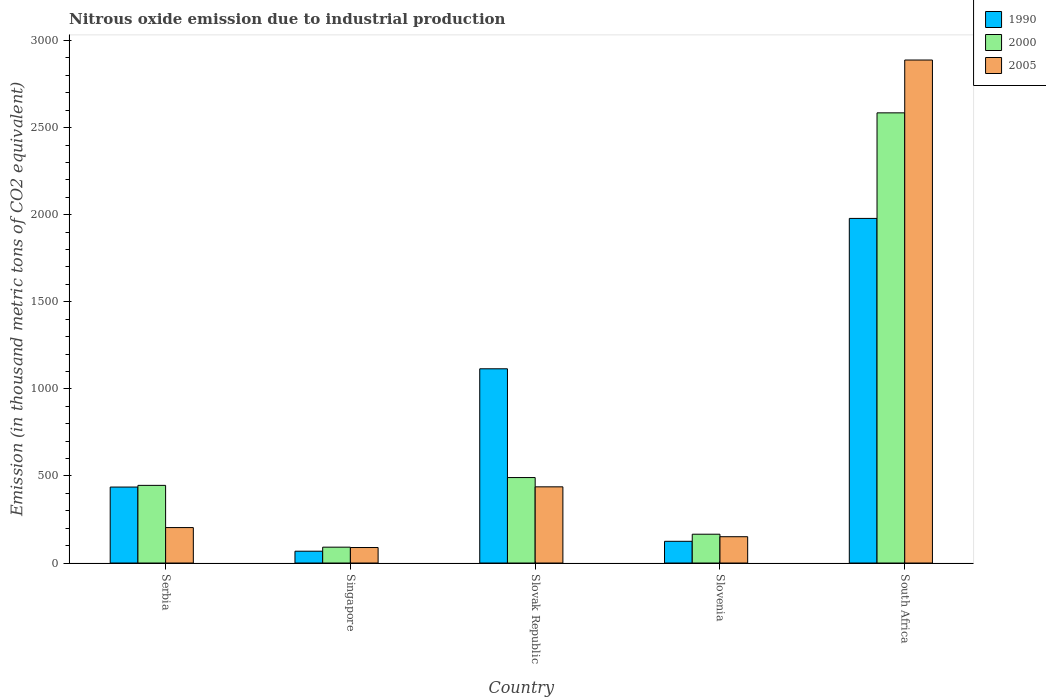How many groups of bars are there?
Offer a terse response. 5. How many bars are there on the 5th tick from the left?
Offer a terse response. 3. What is the label of the 1st group of bars from the left?
Give a very brief answer. Serbia. What is the amount of nitrous oxide emitted in 2000 in Slovak Republic?
Provide a succinct answer. 490.8. Across all countries, what is the maximum amount of nitrous oxide emitted in 1990?
Keep it short and to the point. 1978.6. Across all countries, what is the minimum amount of nitrous oxide emitted in 1990?
Ensure brevity in your answer.  67.9. In which country was the amount of nitrous oxide emitted in 2000 maximum?
Ensure brevity in your answer.  South Africa. In which country was the amount of nitrous oxide emitted in 1990 minimum?
Make the answer very short. Singapore. What is the total amount of nitrous oxide emitted in 2000 in the graph?
Provide a succinct answer. 3778. What is the difference between the amount of nitrous oxide emitted in 2005 in Singapore and that in Slovak Republic?
Give a very brief answer. -348.5. What is the difference between the amount of nitrous oxide emitted in 2000 in Serbia and the amount of nitrous oxide emitted in 1990 in Slovenia?
Give a very brief answer. 321.2. What is the average amount of nitrous oxide emitted in 1990 per country?
Offer a very short reply. 744.52. What is the difference between the amount of nitrous oxide emitted of/in 2000 and amount of nitrous oxide emitted of/in 1990 in Singapore?
Ensure brevity in your answer.  23.2. In how many countries, is the amount of nitrous oxide emitted in 1990 greater than 2700 thousand metric tons?
Keep it short and to the point. 0. What is the ratio of the amount of nitrous oxide emitted in 1990 in Singapore to that in Slovak Republic?
Offer a very short reply. 0.06. Is the amount of nitrous oxide emitted in 1990 in Serbia less than that in Slovak Republic?
Give a very brief answer. Yes. Is the difference between the amount of nitrous oxide emitted in 2000 in Slovenia and South Africa greater than the difference between the amount of nitrous oxide emitted in 1990 in Slovenia and South Africa?
Offer a very short reply. No. What is the difference between the highest and the second highest amount of nitrous oxide emitted in 1990?
Your answer should be compact. 863.4. What is the difference between the highest and the lowest amount of nitrous oxide emitted in 1990?
Keep it short and to the point. 1910.7. In how many countries, is the amount of nitrous oxide emitted in 2005 greater than the average amount of nitrous oxide emitted in 2005 taken over all countries?
Your answer should be compact. 1. What does the 2nd bar from the left in Singapore represents?
Keep it short and to the point. 2000. How many bars are there?
Provide a succinct answer. 15. Are all the bars in the graph horizontal?
Keep it short and to the point. No. Are the values on the major ticks of Y-axis written in scientific E-notation?
Provide a succinct answer. No. Does the graph contain grids?
Your answer should be compact. No. How are the legend labels stacked?
Ensure brevity in your answer.  Vertical. What is the title of the graph?
Make the answer very short. Nitrous oxide emission due to industrial production. Does "1994" appear as one of the legend labels in the graph?
Provide a succinct answer. No. What is the label or title of the X-axis?
Make the answer very short. Country. What is the label or title of the Y-axis?
Keep it short and to the point. Emission (in thousand metric tons of CO2 equivalent). What is the Emission (in thousand metric tons of CO2 equivalent) in 1990 in Serbia?
Ensure brevity in your answer.  436.2. What is the Emission (in thousand metric tons of CO2 equivalent) in 2000 in Serbia?
Give a very brief answer. 445.9. What is the Emission (in thousand metric tons of CO2 equivalent) of 2005 in Serbia?
Your answer should be compact. 203.6. What is the Emission (in thousand metric tons of CO2 equivalent) in 1990 in Singapore?
Offer a terse response. 67.9. What is the Emission (in thousand metric tons of CO2 equivalent) of 2000 in Singapore?
Make the answer very short. 91.1. What is the Emission (in thousand metric tons of CO2 equivalent) of 2005 in Singapore?
Your answer should be compact. 89. What is the Emission (in thousand metric tons of CO2 equivalent) of 1990 in Slovak Republic?
Your response must be concise. 1115.2. What is the Emission (in thousand metric tons of CO2 equivalent) in 2000 in Slovak Republic?
Give a very brief answer. 490.8. What is the Emission (in thousand metric tons of CO2 equivalent) in 2005 in Slovak Republic?
Make the answer very short. 437.5. What is the Emission (in thousand metric tons of CO2 equivalent) of 1990 in Slovenia?
Your response must be concise. 124.7. What is the Emission (in thousand metric tons of CO2 equivalent) in 2000 in Slovenia?
Offer a terse response. 165.5. What is the Emission (in thousand metric tons of CO2 equivalent) in 2005 in Slovenia?
Ensure brevity in your answer.  151.1. What is the Emission (in thousand metric tons of CO2 equivalent) in 1990 in South Africa?
Offer a very short reply. 1978.6. What is the Emission (in thousand metric tons of CO2 equivalent) of 2000 in South Africa?
Offer a terse response. 2584.7. What is the Emission (in thousand metric tons of CO2 equivalent) of 2005 in South Africa?
Your answer should be very brief. 2888. Across all countries, what is the maximum Emission (in thousand metric tons of CO2 equivalent) in 1990?
Ensure brevity in your answer.  1978.6. Across all countries, what is the maximum Emission (in thousand metric tons of CO2 equivalent) in 2000?
Keep it short and to the point. 2584.7. Across all countries, what is the maximum Emission (in thousand metric tons of CO2 equivalent) in 2005?
Provide a short and direct response. 2888. Across all countries, what is the minimum Emission (in thousand metric tons of CO2 equivalent) in 1990?
Give a very brief answer. 67.9. Across all countries, what is the minimum Emission (in thousand metric tons of CO2 equivalent) in 2000?
Your response must be concise. 91.1. Across all countries, what is the minimum Emission (in thousand metric tons of CO2 equivalent) of 2005?
Offer a terse response. 89. What is the total Emission (in thousand metric tons of CO2 equivalent) of 1990 in the graph?
Ensure brevity in your answer.  3722.6. What is the total Emission (in thousand metric tons of CO2 equivalent) in 2000 in the graph?
Make the answer very short. 3778. What is the total Emission (in thousand metric tons of CO2 equivalent) in 2005 in the graph?
Your answer should be compact. 3769.2. What is the difference between the Emission (in thousand metric tons of CO2 equivalent) of 1990 in Serbia and that in Singapore?
Keep it short and to the point. 368.3. What is the difference between the Emission (in thousand metric tons of CO2 equivalent) in 2000 in Serbia and that in Singapore?
Your answer should be compact. 354.8. What is the difference between the Emission (in thousand metric tons of CO2 equivalent) in 2005 in Serbia and that in Singapore?
Provide a succinct answer. 114.6. What is the difference between the Emission (in thousand metric tons of CO2 equivalent) in 1990 in Serbia and that in Slovak Republic?
Your response must be concise. -679. What is the difference between the Emission (in thousand metric tons of CO2 equivalent) of 2000 in Serbia and that in Slovak Republic?
Your response must be concise. -44.9. What is the difference between the Emission (in thousand metric tons of CO2 equivalent) of 2005 in Serbia and that in Slovak Republic?
Offer a terse response. -233.9. What is the difference between the Emission (in thousand metric tons of CO2 equivalent) of 1990 in Serbia and that in Slovenia?
Offer a very short reply. 311.5. What is the difference between the Emission (in thousand metric tons of CO2 equivalent) in 2000 in Serbia and that in Slovenia?
Make the answer very short. 280.4. What is the difference between the Emission (in thousand metric tons of CO2 equivalent) of 2005 in Serbia and that in Slovenia?
Offer a very short reply. 52.5. What is the difference between the Emission (in thousand metric tons of CO2 equivalent) in 1990 in Serbia and that in South Africa?
Provide a succinct answer. -1542.4. What is the difference between the Emission (in thousand metric tons of CO2 equivalent) in 2000 in Serbia and that in South Africa?
Offer a very short reply. -2138.8. What is the difference between the Emission (in thousand metric tons of CO2 equivalent) of 2005 in Serbia and that in South Africa?
Your response must be concise. -2684.4. What is the difference between the Emission (in thousand metric tons of CO2 equivalent) of 1990 in Singapore and that in Slovak Republic?
Offer a terse response. -1047.3. What is the difference between the Emission (in thousand metric tons of CO2 equivalent) in 2000 in Singapore and that in Slovak Republic?
Provide a succinct answer. -399.7. What is the difference between the Emission (in thousand metric tons of CO2 equivalent) of 2005 in Singapore and that in Slovak Republic?
Provide a succinct answer. -348.5. What is the difference between the Emission (in thousand metric tons of CO2 equivalent) of 1990 in Singapore and that in Slovenia?
Keep it short and to the point. -56.8. What is the difference between the Emission (in thousand metric tons of CO2 equivalent) of 2000 in Singapore and that in Slovenia?
Provide a succinct answer. -74.4. What is the difference between the Emission (in thousand metric tons of CO2 equivalent) of 2005 in Singapore and that in Slovenia?
Your answer should be compact. -62.1. What is the difference between the Emission (in thousand metric tons of CO2 equivalent) of 1990 in Singapore and that in South Africa?
Provide a succinct answer. -1910.7. What is the difference between the Emission (in thousand metric tons of CO2 equivalent) of 2000 in Singapore and that in South Africa?
Offer a terse response. -2493.6. What is the difference between the Emission (in thousand metric tons of CO2 equivalent) of 2005 in Singapore and that in South Africa?
Keep it short and to the point. -2799. What is the difference between the Emission (in thousand metric tons of CO2 equivalent) of 1990 in Slovak Republic and that in Slovenia?
Your answer should be very brief. 990.5. What is the difference between the Emission (in thousand metric tons of CO2 equivalent) in 2000 in Slovak Republic and that in Slovenia?
Provide a succinct answer. 325.3. What is the difference between the Emission (in thousand metric tons of CO2 equivalent) in 2005 in Slovak Republic and that in Slovenia?
Keep it short and to the point. 286.4. What is the difference between the Emission (in thousand metric tons of CO2 equivalent) of 1990 in Slovak Republic and that in South Africa?
Keep it short and to the point. -863.4. What is the difference between the Emission (in thousand metric tons of CO2 equivalent) of 2000 in Slovak Republic and that in South Africa?
Ensure brevity in your answer.  -2093.9. What is the difference between the Emission (in thousand metric tons of CO2 equivalent) in 2005 in Slovak Republic and that in South Africa?
Provide a short and direct response. -2450.5. What is the difference between the Emission (in thousand metric tons of CO2 equivalent) of 1990 in Slovenia and that in South Africa?
Offer a very short reply. -1853.9. What is the difference between the Emission (in thousand metric tons of CO2 equivalent) of 2000 in Slovenia and that in South Africa?
Give a very brief answer. -2419.2. What is the difference between the Emission (in thousand metric tons of CO2 equivalent) in 2005 in Slovenia and that in South Africa?
Your answer should be very brief. -2736.9. What is the difference between the Emission (in thousand metric tons of CO2 equivalent) in 1990 in Serbia and the Emission (in thousand metric tons of CO2 equivalent) in 2000 in Singapore?
Make the answer very short. 345.1. What is the difference between the Emission (in thousand metric tons of CO2 equivalent) in 1990 in Serbia and the Emission (in thousand metric tons of CO2 equivalent) in 2005 in Singapore?
Provide a succinct answer. 347.2. What is the difference between the Emission (in thousand metric tons of CO2 equivalent) in 2000 in Serbia and the Emission (in thousand metric tons of CO2 equivalent) in 2005 in Singapore?
Provide a short and direct response. 356.9. What is the difference between the Emission (in thousand metric tons of CO2 equivalent) of 1990 in Serbia and the Emission (in thousand metric tons of CO2 equivalent) of 2000 in Slovak Republic?
Your answer should be compact. -54.6. What is the difference between the Emission (in thousand metric tons of CO2 equivalent) of 1990 in Serbia and the Emission (in thousand metric tons of CO2 equivalent) of 2005 in Slovak Republic?
Provide a succinct answer. -1.3. What is the difference between the Emission (in thousand metric tons of CO2 equivalent) of 1990 in Serbia and the Emission (in thousand metric tons of CO2 equivalent) of 2000 in Slovenia?
Offer a terse response. 270.7. What is the difference between the Emission (in thousand metric tons of CO2 equivalent) of 1990 in Serbia and the Emission (in thousand metric tons of CO2 equivalent) of 2005 in Slovenia?
Your response must be concise. 285.1. What is the difference between the Emission (in thousand metric tons of CO2 equivalent) of 2000 in Serbia and the Emission (in thousand metric tons of CO2 equivalent) of 2005 in Slovenia?
Your answer should be compact. 294.8. What is the difference between the Emission (in thousand metric tons of CO2 equivalent) in 1990 in Serbia and the Emission (in thousand metric tons of CO2 equivalent) in 2000 in South Africa?
Give a very brief answer. -2148.5. What is the difference between the Emission (in thousand metric tons of CO2 equivalent) in 1990 in Serbia and the Emission (in thousand metric tons of CO2 equivalent) in 2005 in South Africa?
Provide a succinct answer. -2451.8. What is the difference between the Emission (in thousand metric tons of CO2 equivalent) in 2000 in Serbia and the Emission (in thousand metric tons of CO2 equivalent) in 2005 in South Africa?
Ensure brevity in your answer.  -2442.1. What is the difference between the Emission (in thousand metric tons of CO2 equivalent) in 1990 in Singapore and the Emission (in thousand metric tons of CO2 equivalent) in 2000 in Slovak Republic?
Offer a very short reply. -422.9. What is the difference between the Emission (in thousand metric tons of CO2 equivalent) in 1990 in Singapore and the Emission (in thousand metric tons of CO2 equivalent) in 2005 in Slovak Republic?
Offer a very short reply. -369.6. What is the difference between the Emission (in thousand metric tons of CO2 equivalent) of 2000 in Singapore and the Emission (in thousand metric tons of CO2 equivalent) of 2005 in Slovak Republic?
Provide a succinct answer. -346.4. What is the difference between the Emission (in thousand metric tons of CO2 equivalent) in 1990 in Singapore and the Emission (in thousand metric tons of CO2 equivalent) in 2000 in Slovenia?
Make the answer very short. -97.6. What is the difference between the Emission (in thousand metric tons of CO2 equivalent) of 1990 in Singapore and the Emission (in thousand metric tons of CO2 equivalent) of 2005 in Slovenia?
Offer a very short reply. -83.2. What is the difference between the Emission (in thousand metric tons of CO2 equivalent) of 2000 in Singapore and the Emission (in thousand metric tons of CO2 equivalent) of 2005 in Slovenia?
Provide a succinct answer. -60. What is the difference between the Emission (in thousand metric tons of CO2 equivalent) in 1990 in Singapore and the Emission (in thousand metric tons of CO2 equivalent) in 2000 in South Africa?
Your answer should be very brief. -2516.8. What is the difference between the Emission (in thousand metric tons of CO2 equivalent) in 1990 in Singapore and the Emission (in thousand metric tons of CO2 equivalent) in 2005 in South Africa?
Provide a succinct answer. -2820.1. What is the difference between the Emission (in thousand metric tons of CO2 equivalent) in 2000 in Singapore and the Emission (in thousand metric tons of CO2 equivalent) in 2005 in South Africa?
Your answer should be very brief. -2796.9. What is the difference between the Emission (in thousand metric tons of CO2 equivalent) in 1990 in Slovak Republic and the Emission (in thousand metric tons of CO2 equivalent) in 2000 in Slovenia?
Provide a succinct answer. 949.7. What is the difference between the Emission (in thousand metric tons of CO2 equivalent) in 1990 in Slovak Republic and the Emission (in thousand metric tons of CO2 equivalent) in 2005 in Slovenia?
Ensure brevity in your answer.  964.1. What is the difference between the Emission (in thousand metric tons of CO2 equivalent) of 2000 in Slovak Republic and the Emission (in thousand metric tons of CO2 equivalent) of 2005 in Slovenia?
Your answer should be very brief. 339.7. What is the difference between the Emission (in thousand metric tons of CO2 equivalent) in 1990 in Slovak Republic and the Emission (in thousand metric tons of CO2 equivalent) in 2000 in South Africa?
Your answer should be compact. -1469.5. What is the difference between the Emission (in thousand metric tons of CO2 equivalent) of 1990 in Slovak Republic and the Emission (in thousand metric tons of CO2 equivalent) of 2005 in South Africa?
Make the answer very short. -1772.8. What is the difference between the Emission (in thousand metric tons of CO2 equivalent) in 2000 in Slovak Republic and the Emission (in thousand metric tons of CO2 equivalent) in 2005 in South Africa?
Make the answer very short. -2397.2. What is the difference between the Emission (in thousand metric tons of CO2 equivalent) in 1990 in Slovenia and the Emission (in thousand metric tons of CO2 equivalent) in 2000 in South Africa?
Your response must be concise. -2460. What is the difference between the Emission (in thousand metric tons of CO2 equivalent) in 1990 in Slovenia and the Emission (in thousand metric tons of CO2 equivalent) in 2005 in South Africa?
Your answer should be very brief. -2763.3. What is the difference between the Emission (in thousand metric tons of CO2 equivalent) of 2000 in Slovenia and the Emission (in thousand metric tons of CO2 equivalent) of 2005 in South Africa?
Your response must be concise. -2722.5. What is the average Emission (in thousand metric tons of CO2 equivalent) of 1990 per country?
Your response must be concise. 744.52. What is the average Emission (in thousand metric tons of CO2 equivalent) of 2000 per country?
Provide a succinct answer. 755.6. What is the average Emission (in thousand metric tons of CO2 equivalent) in 2005 per country?
Make the answer very short. 753.84. What is the difference between the Emission (in thousand metric tons of CO2 equivalent) of 1990 and Emission (in thousand metric tons of CO2 equivalent) of 2000 in Serbia?
Your answer should be compact. -9.7. What is the difference between the Emission (in thousand metric tons of CO2 equivalent) in 1990 and Emission (in thousand metric tons of CO2 equivalent) in 2005 in Serbia?
Your answer should be very brief. 232.6. What is the difference between the Emission (in thousand metric tons of CO2 equivalent) in 2000 and Emission (in thousand metric tons of CO2 equivalent) in 2005 in Serbia?
Your response must be concise. 242.3. What is the difference between the Emission (in thousand metric tons of CO2 equivalent) in 1990 and Emission (in thousand metric tons of CO2 equivalent) in 2000 in Singapore?
Ensure brevity in your answer.  -23.2. What is the difference between the Emission (in thousand metric tons of CO2 equivalent) in 1990 and Emission (in thousand metric tons of CO2 equivalent) in 2005 in Singapore?
Provide a short and direct response. -21.1. What is the difference between the Emission (in thousand metric tons of CO2 equivalent) in 1990 and Emission (in thousand metric tons of CO2 equivalent) in 2000 in Slovak Republic?
Ensure brevity in your answer.  624.4. What is the difference between the Emission (in thousand metric tons of CO2 equivalent) in 1990 and Emission (in thousand metric tons of CO2 equivalent) in 2005 in Slovak Republic?
Provide a short and direct response. 677.7. What is the difference between the Emission (in thousand metric tons of CO2 equivalent) in 2000 and Emission (in thousand metric tons of CO2 equivalent) in 2005 in Slovak Republic?
Your response must be concise. 53.3. What is the difference between the Emission (in thousand metric tons of CO2 equivalent) of 1990 and Emission (in thousand metric tons of CO2 equivalent) of 2000 in Slovenia?
Make the answer very short. -40.8. What is the difference between the Emission (in thousand metric tons of CO2 equivalent) in 1990 and Emission (in thousand metric tons of CO2 equivalent) in 2005 in Slovenia?
Provide a short and direct response. -26.4. What is the difference between the Emission (in thousand metric tons of CO2 equivalent) in 1990 and Emission (in thousand metric tons of CO2 equivalent) in 2000 in South Africa?
Your answer should be compact. -606.1. What is the difference between the Emission (in thousand metric tons of CO2 equivalent) of 1990 and Emission (in thousand metric tons of CO2 equivalent) of 2005 in South Africa?
Your answer should be compact. -909.4. What is the difference between the Emission (in thousand metric tons of CO2 equivalent) in 2000 and Emission (in thousand metric tons of CO2 equivalent) in 2005 in South Africa?
Provide a succinct answer. -303.3. What is the ratio of the Emission (in thousand metric tons of CO2 equivalent) of 1990 in Serbia to that in Singapore?
Make the answer very short. 6.42. What is the ratio of the Emission (in thousand metric tons of CO2 equivalent) of 2000 in Serbia to that in Singapore?
Provide a short and direct response. 4.89. What is the ratio of the Emission (in thousand metric tons of CO2 equivalent) of 2005 in Serbia to that in Singapore?
Your response must be concise. 2.29. What is the ratio of the Emission (in thousand metric tons of CO2 equivalent) in 1990 in Serbia to that in Slovak Republic?
Keep it short and to the point. 0.39. What is the ratio of the Emission (in thousand metric tons of CO2 equivalent) in 2000 in Serbia to that in Slovak Republic?
Give a very brief answer. 0.91. What is the ratio of the Emission (in thousand metric tons of CO2 equivalent) in 2005 in Serbia to that in Slovak Republic?
Your answer should be very brief. 0.47. What is the ratio of the Emission (in thousand metric tons of CO2 equivalent) of 1990 in Serbia to that in Slovenia?
Make the answer very short. 3.5. What is the ratio of the Emission (in thousand metric tons of CO2 equivalent) of 2000 in Serbia to that in Slovenia?
Offer a very short reply. 2.69. What is the ratio of the Emission (in thousand metric tons of CO2 equivalent) in 2005 in Serbia to that in Slovenia?
Your answer should be very brief. 1.35. What is the ratio of the Emission (in thousand metric tons of CO2 equivalent) in 1990 in Serbia to that in South Africa?
Your response must be concise. 0.22. What is the ratio of the Emission (in thousand metric tons of CO2 equivalent) of 2000 in Serbia to that in South Africa?
Offer a terse response. 0.17. What is the ratio of the Emission (in thousand metric tons of CO2 equivalent) in 2005 in Serbia to that in South Africa?
Give a very brief answer. 0.07. What is the ratio of the Emission (in thousand metric tons of CO2 equivalent) of 1990 in Singapore to that in Slovak Republic?
Provide a succinct answer. 0.06. What is the ratio of the Emission (in thousand metric tons of CO2 equivalent) in 2000 in Singapore to that in Slovak Republic?
Offer a very short reply. 0.19. What is the ratio of the Emission (in thousand metric tons of CO2 equivalent) in 2005 in Singapore to that in Slovak Republic?
Your answer should be compact. 0.2. What is the ratio of the Emission (in thousand metric tons of CO2 equivalent) of 1990 in Singapore to that in Slovenia?
Make the answer very short. 0.54. What is the ratio of the Emission (in thousand metric tons of CO2 equivalent) of 2000 in Singapore to that in Slovenia?
Give a very brief answer. 0.55. What is the ratio of the Emission (in thousand metric tons of CO2 equivalent) of 2005 in Singapore to that in Slovenia?
Offer a terse response. 0.59. What is the ratio of the Emission (in thousand metric tons of CO2 equivalent) in 1990 in Singapore to that in South Africa?
Offer a very short reply. 0.03. What is the ratio of the Emission (in thousand metric tons of CO2 equivalent) in 2000 in Singapore to that in South Africa?
Ensure brevity in your answer.  0.04. What is the ratio of the Emission (in thousand metric tons of CO2 equivalent) in 2005 in Singapore to that in South Africa?
Make the answer very short. 0.03. What is the ratio of the Emission (in thousand metric tons of CO2 equivalent) in 1990 in Slovak Republic to that in Slovenia?
Offer a very short reply. 8.94. What is the ratio of the Emission (in thousand metric tons of CO2 equivalent) in 2000 in Slovak Republic to that in Slovenia?
Your answer should be compact. 2.97. What is the ratio of the Emission (in thousand metric tons of CO2 equivalent) of 2005 in Slovak Republic to that in Slovenia?
Your response must be concise. 2.9. What is the ratio of the Emission (in thousand metric tons of CO2 equivalent) in 1990 in Slovak Republic to that in South Africa?
Provide a short and direct response. 0.56. What is the ratio of the Emission (in thousand metric tons of CO2 equivalent) in 2000 in Slovak Republic to that in South Africa?
Offer a very short reply. 0.19. What is the ratio of the Emission (in thousand metric tons of CO2 equivalent) of 2005 in Slovak Republic to that in South Africa?
Keep it short and to the point. 0.15. What is the ratio of the Emission (in thousand metric tons of CO2 equivalent) in 1990 in Slovenia to that in South Africa?
Make the answer very short. 0.06. What is the ratio of the Emission (in thousand metric tons of CO2 equivalent) of 2000 in Slovenia to that in South Africa?
Your answer should be compact. 0.06. What is the ratio of the Emission (in thousand metric tons of CO2 equivalent) of 2005 in Slovenia to that in South Africa?
Your answer should be compact. 0.05. What is the difference between the highest and the second highest Emission (in thousand metric tons of CO2 equivalent) in 1990?
Provide a succinct answer. 863.4. What is the difference between the highest and the second highest Emission (in thousand metric tons of CO2 equivalent) in 2000?
Offer a very short reply. 2093.9. What is the difference between the highest and the second highest Emission (in thousand metric tons of CO2 equivalent) of 2005?
Ensure brevity in your answer.  2450.5. What is the difference between the highest and the lowest Emission (in thousand metric tons of CO2 equivalent) of 1990?
Your answer should be compact. 1910.7. What is the difference between the highest and the lowest Emission (in thousand metric tons of CO2 equivalent) of 2000?
Keep it short and to the point. 2493.6. What is the difference between the highest and the lowest Emission (in thousand metric tons of CO2 equivalent) of 2005?
Make the answer very short. 2799. 